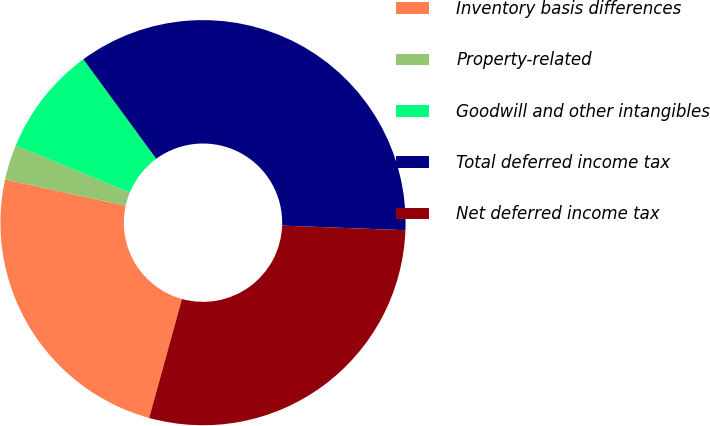Convert chart. <chart><loc_0><loc_0><loc_500><loc_500><pie_chart><fcel>Inventory basis differences<fcel>Property-related<fcel>Goodwill and other intangibles<fcel>Total deferred income tax<fcel>Net deferred income tax<nl><fcel>24.14%<fcel>2.8%<fcel>8.72%<fcel>35.65%<fcel>28.69%<nl></chart> 